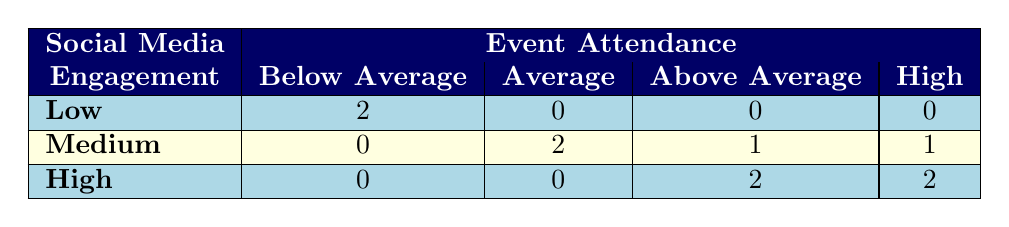What is the number of events with low social media engagement and below average attendance? There are 2 events listed under the "Low" social media engagement category, and both of them have "Below Average" attendance.
Answer: 2 What is the attendance level for events that had medium social media engagement? The table shows that for medium social media engagement, there are 0 events with below average attendance, 2 with average attendance, 1 with above average attendance, and 1 with high attendance.
Answer: 0 below average, 2 average, 1 above average, 1 high Are there any events with high social media engagement and average attendance? The table indicates that there are no events categorized under "High" social media engagement with "Average" attendance, as all events in this row have attendance levels of "Above Average" or "High."
Answer: No What is the total number of events with high attendance, regardless of social media engagement? From the table, there are 3 events categorized with high attendance (2 with high social media engagement and 1 with medium engagement). Adding these gives a total of 3 events.
Answer: 3 How does the number of events with medium social media engagement differ from those with high engagement? The table shows 4 events with medium social media engagement and 4 events with high engagement. The difference between these two is 4 - 4 = 0.
Answer: 0 difference What percentage of total events had high social media engagement and high attendance? There are 4 events with high social media engagement and 2 of those have high attendance. To find the percentage, we calculate (2 / 10) * 100 = 20%.
Answer: 20% Are there any events with low social media engagement and high attendance? The table clearly states that there are 0 events listed under low social media engagement that have high attendance.
Answer: No How many events had average attendance and did not have high social media engagement? The medium engagement category shows 2 events with average attendance, and low engagement shows 0 events with average attendance. Thus, a total of 2 events had average attendance without high social media engagement.
Answer: 2 